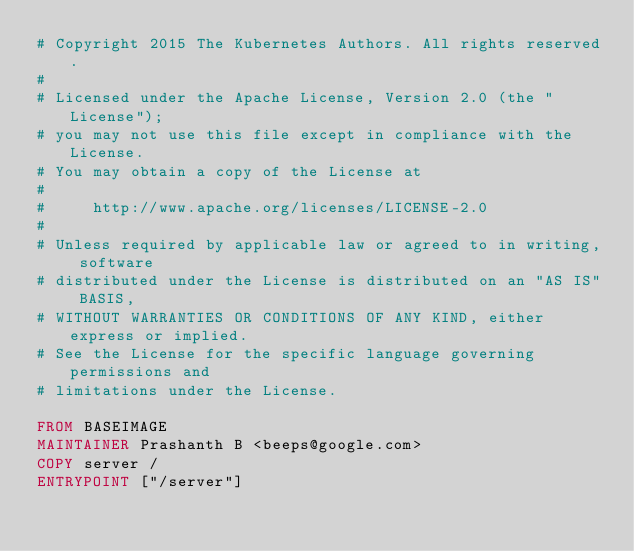Convert code to text. <code><loc_0><loc_0><loc_500><loc_500><_Dockerfile_># Copyright 2015 The Kubernetes Authors. All rights reserved.
#
# Licensed under the Apache License, Version 2.0 (the "License");
# you may not use this file except in compliance with the License.
# You may obtain a copy of the License at
#
#     http://www.apache.org/licenses/LICENSE-2.0
#
# Unless required by applicable law or agreed to in writing, software
# distributed under the License is distributed on an "AS IS" BASIS,
# WITHOUT WARRANTIES OR CONDITIONS OF ANY KIND, either express or implied.
# See the License for the specific language governing permissions and
# limitations under the License.

FROM BASEIMAGE
MAINTAINER Prashanth B <beeps@google.com>
COPY server /
ENTRYPOINT ["/server"]
</code> 